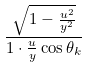<formula> <loc_0><loc_0><loc_500><loc_500>\frac { \sqrt { 1 - \frac { u ^ { 2 } } { y ^ { 2 } } } } { 1 \cdot \frac { u } { y } \cos \theta _ { k } }</formula> 